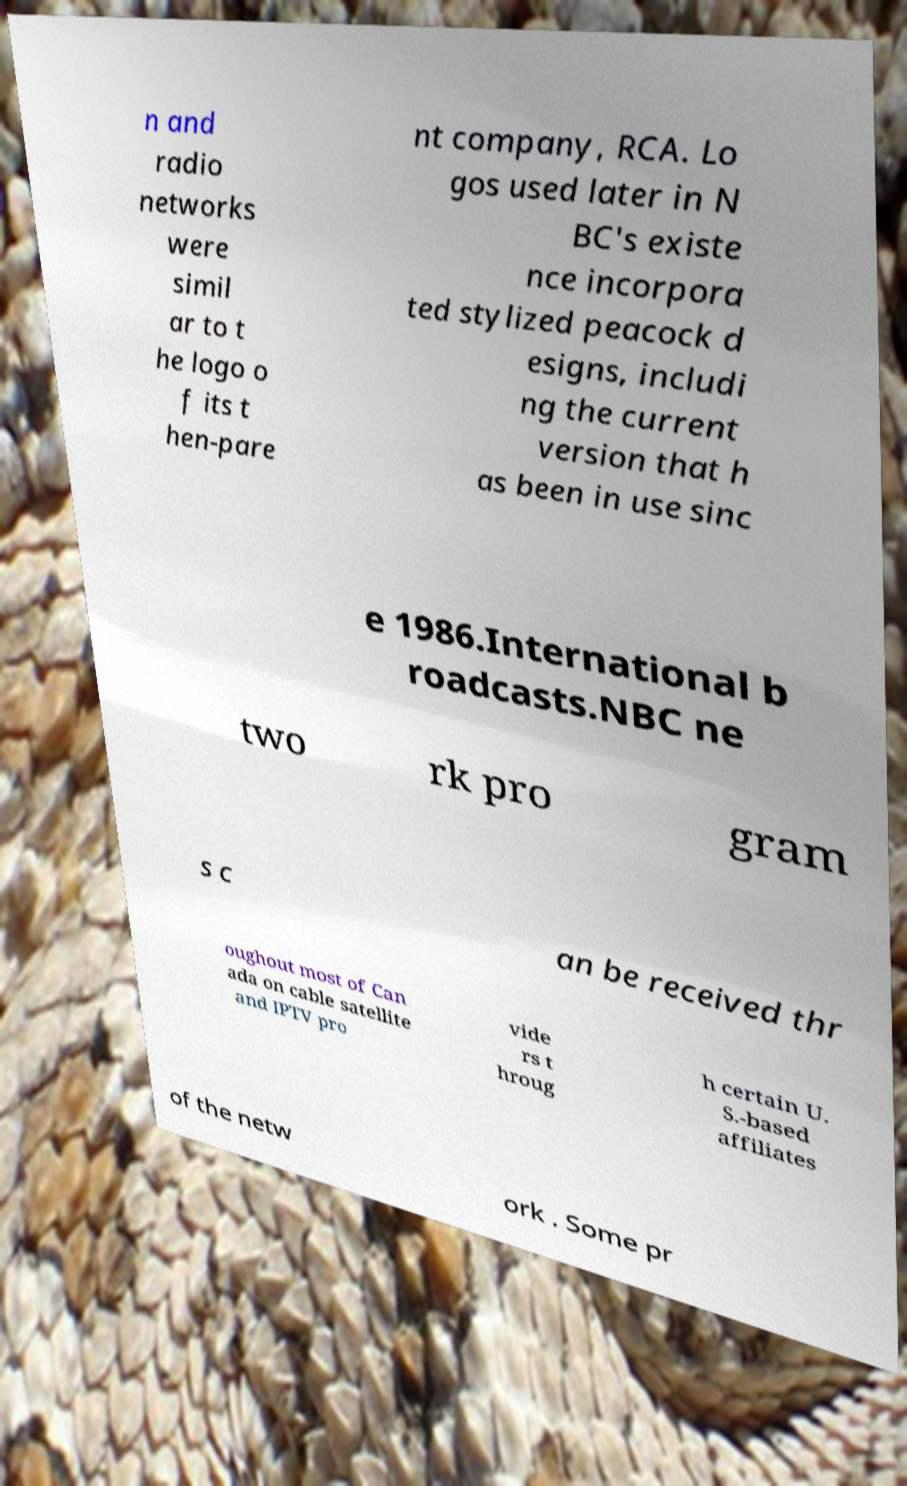I need the written content from this picture converted into text. Can you do that? n and radio networks were simil ar to t he logo o f its t hen-pare nt company, RCA. Lo gos used later in N BC's existe nce incorpora ted stylized peacock d esigns, includi ng the current version that h as been in use sinc e 1986.International b roadcasts.NBC ne two rk pro gram s c an be received thr oughout most of Can ada on cable satellite and IPTV pro vide rs t hroug h certain U. S.-based affiliates of the netw ork . Some pr 